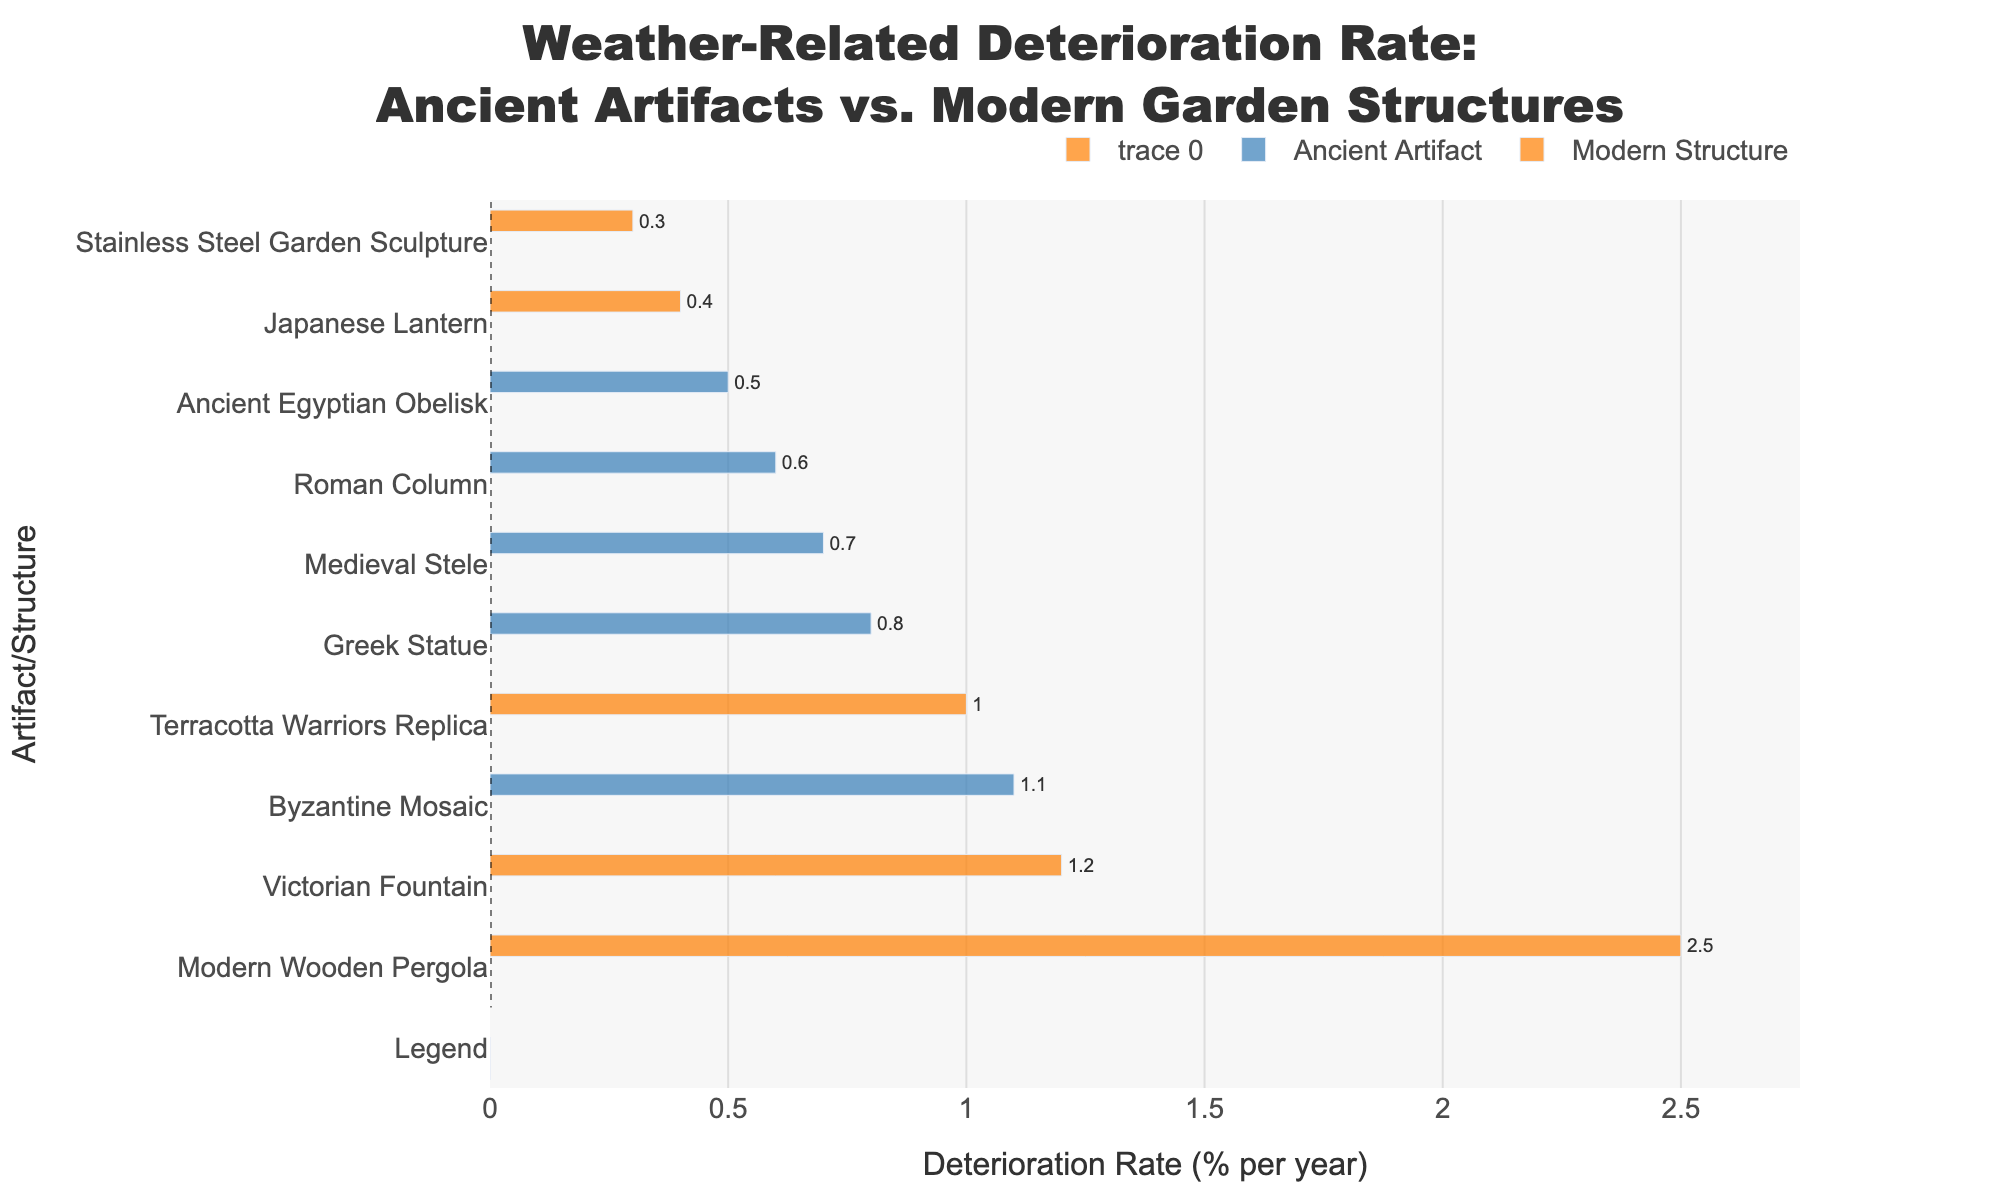What's the weather-related deterioration rate of the Greek Statue? Locate the bar representing the Greek Statue. The text outside the bar shows the deterioration rate of 0.8% per year.
Answer: 0.8% Which ancient artifact has the lowest weather-related deterioration rate, and what is the rate? Scan the labels under "Ancient Artifact" and identify the bar with the smallest length, which corresponds to the Ancient Egyptian Obelisk with a rate of 0.5% per year.
Answer: Ancient Egyptian Obelisk, 0.5% How much higher is the deterioration rate of the Victorian Fountain compared to the Roman Column? The Victorian Fountain has a rate of 1.2% per year and the Roman Column has 0.6%. The difference is 1.2 - 0.6 = 0.6%.
Answer: 0.6% Which modern structure has the highest weather-related deterioration rate? Among the bars representing "Modern Structure," identify the longest one, which is the Modern Wooden Pergola.
Answer: Modern Wooden Pergola What's the average deterioration rate for all ancient artifacts? Calculate the sum of deterioration rates for ancient artifacts: 0.6 + 0.8 + 0.7 + 0.5 + 1.1 = 3.7. Divide by the number of artifacts: 3.7 / 5 = 0.74%.
Answer: 0.74% How does the deterioration rate of the Byzantine Mosaic compare to the Japanese Lantern? The Byzantine Mosaic has a rate of 1.1% per year and the Japanese Lantern has 0.4%. Since 1.1% is greater than 0.4%, the Byzantine Mosaic deteriorates faster.
Answer: Byzantine Mosaic deteriorates faster What is the median weather-related deterioration rate for all listed items? Sort the rates: 0.3, 0.4, 0.5, 0.6, 0.7, 0.8, 1.0, 1.1, 1.2, 2.5. The median is the middle value: 0.75 (average of 0.7 and 0.8, the 5th and 6th values).
Answer: 0.75% What color represents modern structures in the chart? Observing the legend, modern structures are marked in orange.
Answer: Orange Which has a lower weather-related deterioration rate: The Terracotta Warriors Replica or the Roman Column? Compare the rates: Terracotta Warriors Replica has 1.0% and Roman Column has 0.6%. The Roman Column has a lower rate.
Answer: Roman Column 